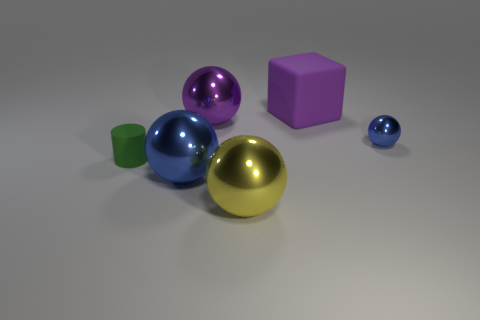Add 2 rubber objects. How many objects exist? 8 Subtract all spheres. How many objects are left? 2 Add 4 tiny balls. How many tiny balls are left? 5 Add 6 large brown shiny objects. How many large brown shiny objects exist? 6 Subtract 1 purple balls. How many objects are left? 5 Subtract all red spheres. Subtract all big blue metal objects. How many objects are left? 5 